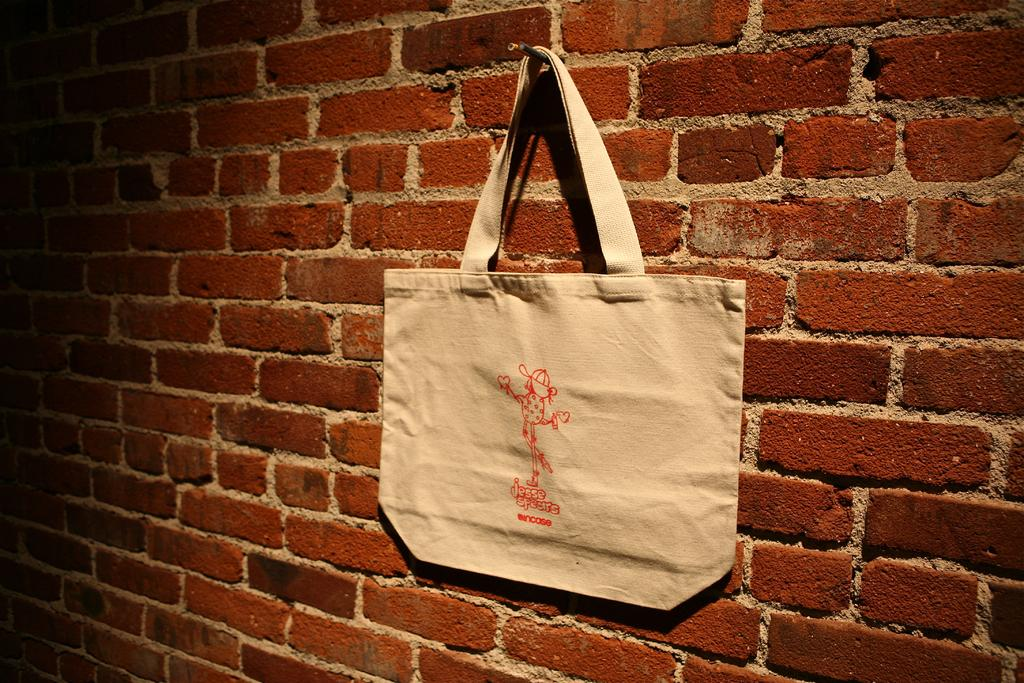What is the color of the wall in the image? The wall in the image is brown. What is the color of the bag in the image? The bag in the image is white. How is the bag positioned in relation to the wall? The bag is hanging on the wall. What type of beast can be seen roaming on the ground in the image? There is no beast or ground visible in the image; it only features a brown brick wall and a white bag hanging on it. 